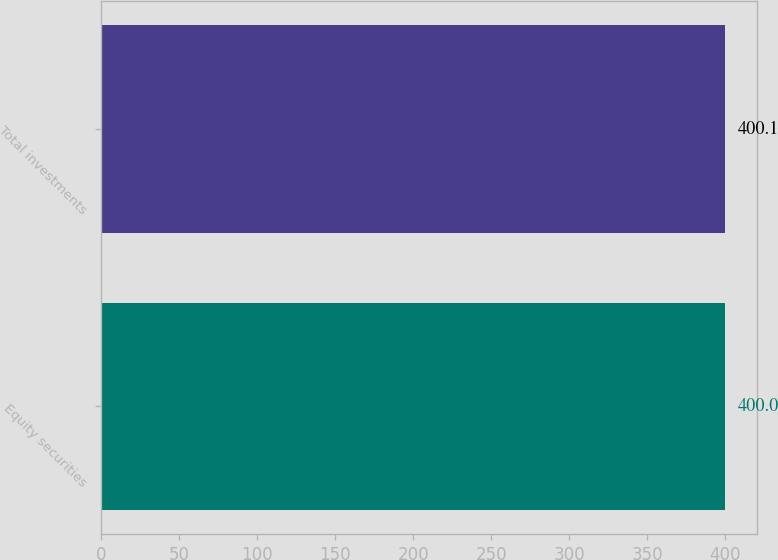Convert chart to OTSL. <chart><loc_0><loc_0><loc_500><loc_500><bar_chart><fcel>Equity securities<fcel>Total investments<nl><fcel>400<fcel>400.1<nl></chart> 